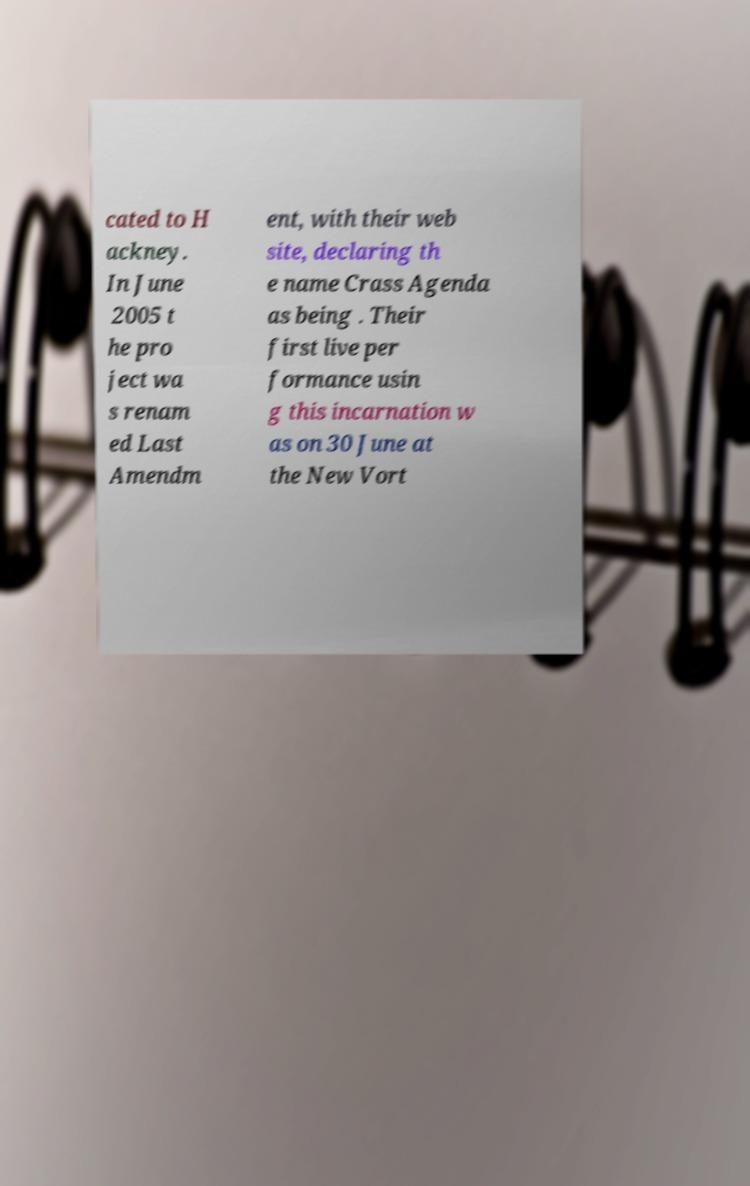Can you accurately transcribe the text from the provided image for me? cated to H ackney. In June 2005 t he pro ject wa s renam ed Last Amendm ent, with their web site, declaring th e name Crass Agenda as being . Their first live per formance usin g this incarnation w as on 30 June at the New Vort 